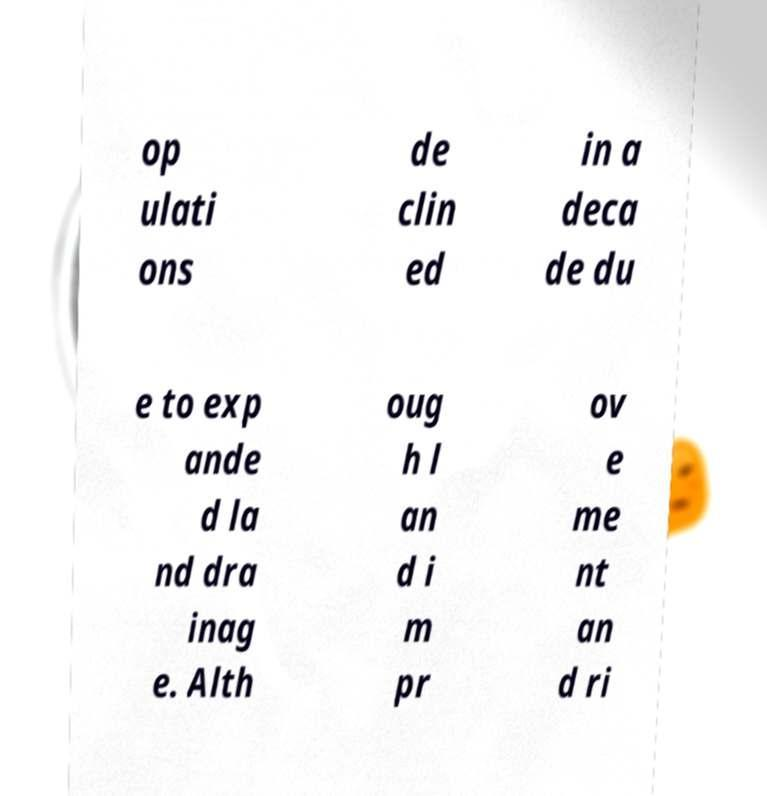Please identify and transcribe the text found in this image. op ulati ons de clin ed in a deca de du e to exp ande d la nd dra inag e. Alth oug h l an d i m pr ov e me nt an d ri 